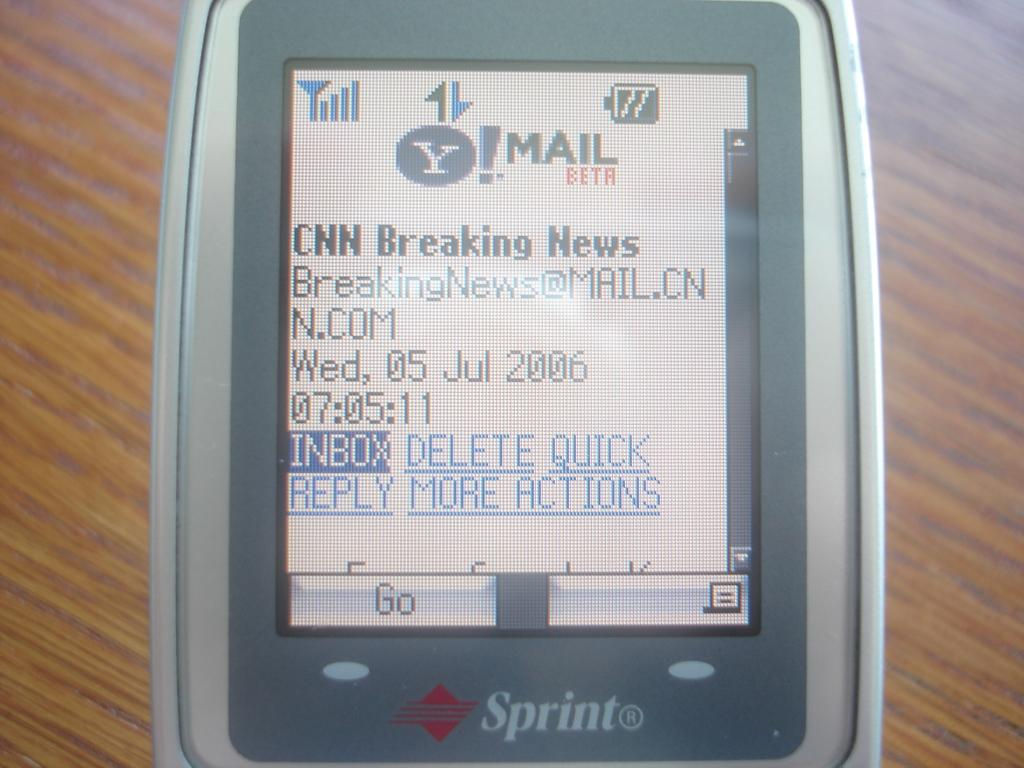<image>
Create a compact narrative representing the image presented. older sprint phone with cnn breaking news on screen and date of july 5, 2006 